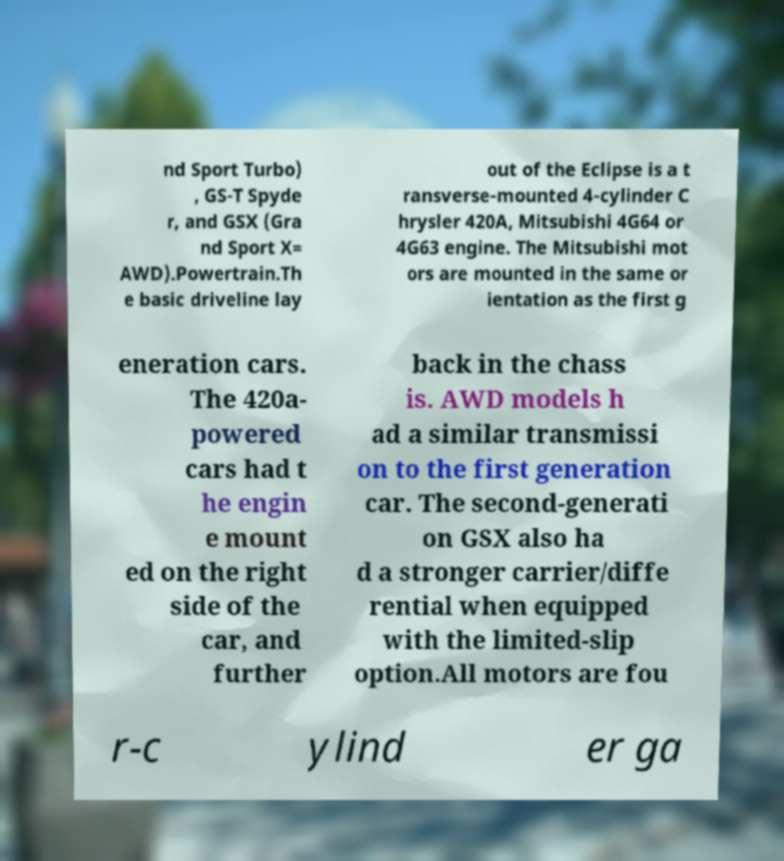Could you extract and type out the text from this image? nd Sport Turbo) , GS-T Spyde r, and GSX (Gra nd Sport X= AWD).Powertrain.Th e basic driveline lay out of the Eclipse is a t ransverse-mounted 4-cylinder C hrysler 420A, Mitsubishi 4G64 or 4G63 engine. The Mitsubishi mot ors are mounted in the same or ientation as the first g eneration cars. The 420a- powered cars had t he engin e mount ed on the right side of the car, and further back in the chass is. AWD models h ad a similar transmissi on to the first generation car. The second-generati on GSX also ha d a stronger carrier/diffe rential when equipped with the limited-slip option.All motors are fou r-c ylind er ga 